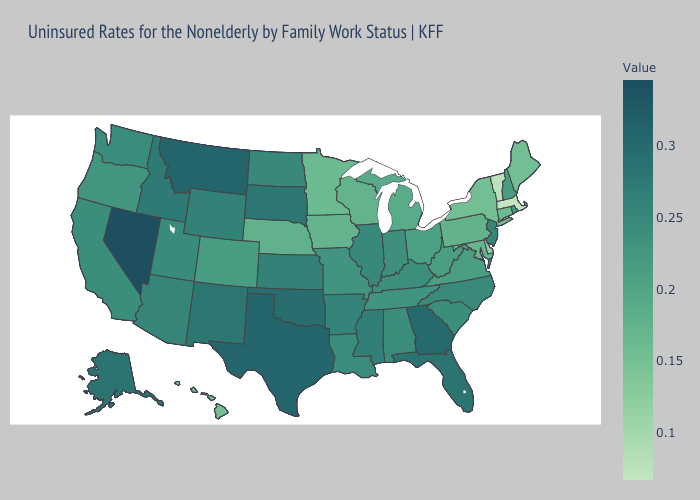Does Kansas have the highest value in the USA?
Concise answer only. No. Among the states that border Montana , which have the lowest value?
Be succinct. North Dakota. Which states have the lowest value in the Northeast?
Answer briefly. Massachusetts. Does Delaware have the lowest value in the South?
Write a very short answer. Yes. Does Minnesota have the lowest value in the MidWest?
Write a very short answer. Yes. 